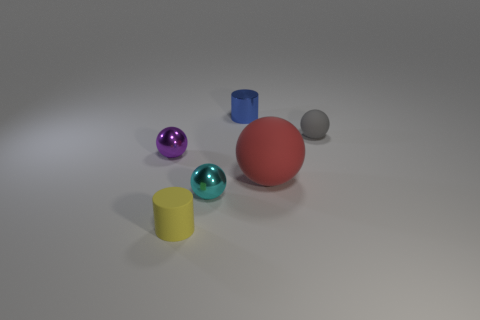Subtract all large balls. How many balls are left? 3 Add 1 tiny shiny balls. How many objects exist? 7 Subtract all yellow cylinders. How many cylinders are left? 1 Subtract all cylinders. How many objects are left? 4 Subtract 3 spheres. How many spheres are left? 1 Add 5 purple things. How many purple things are left? 6 Add 4 large rubber spheres. How many large rubber spheres exist? 5 Subtract 0 brown balls. How many objects are left? 6 Subtract all purple cylinders. Subtract all blue spheres. How many cylinders are left? 2 Subtract all red spheres. How many purple cylinders are left? 0 